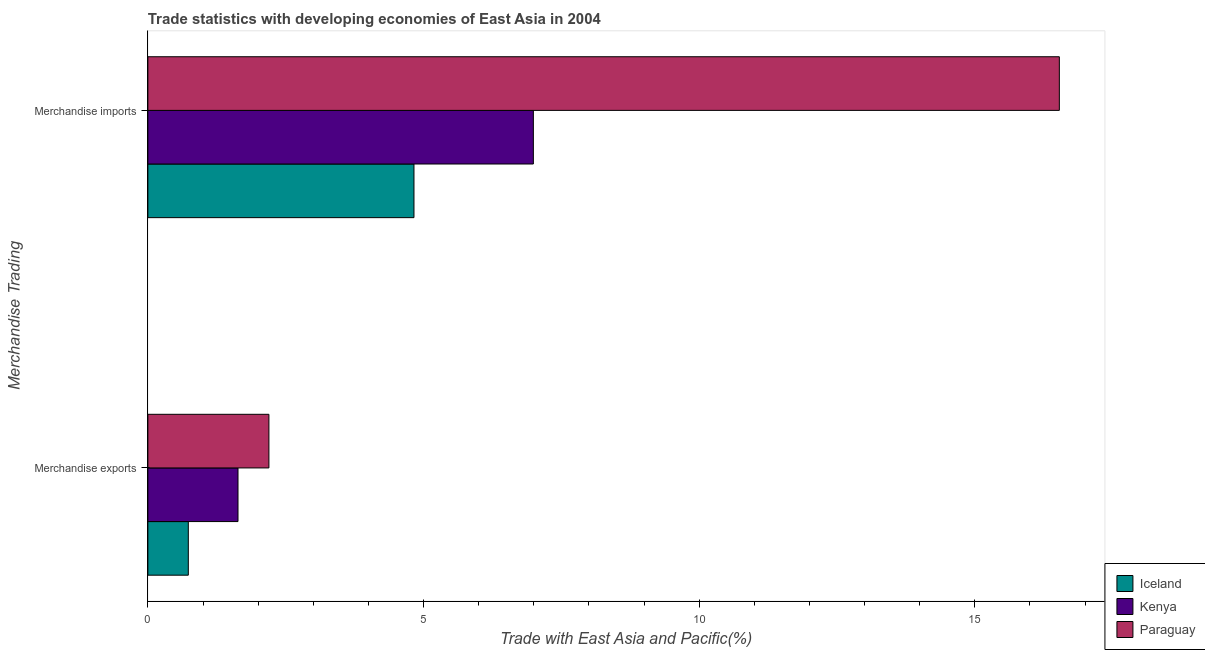How many groups of bars are there?
Provide a succinct answer. 2. Are the number of bars per tick equal to the number of legend labels?
Give a very brief answer. Yes. Are the number of bars on each tick of the Y-axis equal?
Offer a terse response. Yes. How many bars are there on the 1st tick from the bottom?
Provide a short and direct response. 3. What is the label of the 2nd group of bars from the top?
Keep it short and to the point. Merchandise exports. What is the merchandise imports in Kenya?
Ensure brevity in your answer.  6.99. Across all countries, what is the maximum merchandise imports?
Your answer should be compact. 16.53. Across all countries, what is the minimum merchandise imports?
Provide a succinct answer. 4.83. In which country was the merchandise exports maximum?
Provide a succinct answer. Paraguay. What is the total merchandise imports in the graph?
Provide a short and direct response. 28.35. What is the difference between the merchandise imports in Kenya and that in Iceland?
Make the answer very short. 2.17. What is the difference between the merchandise imports in Iceland and the merchandise exports in Kenya?
Offer a terse response. 3.19. What is the average merchandise imports per country?
Your answer should be very brief. 9.45. What is the difference between the merchandise imports and merchandise exports in Kenya?
Provide a short and direct response. 5.36. What is the ratio of the merchandise imports in Iceland to that in Kenya?
Provide a short and direct response. 0.69. In how many countries, is the merchandise imports greater than the average merchandise imports taken over all countries?
Offer a very short reply. 1. What does the 2nd bar from the top in Merchandise imports represents?
Make the answer very short. Kenya. What does the 2nd bar from the bottom in Merchandise imports represents?
Provide a short and direct response. Kenya. How many countries are there in the graph?
Your answer should be compact. 3. Are the values on the major ticks of X-axis written in scientific E-notation?
Provide a succinct answer. No. Does the graph contain any zero values?
Keep it short and to the point. No. Does the graph contain grids?
Keep it short and to the point. No. What is the title of the graph?
Offer a terse response. Trade statistics with developing economies of East Asia in 2004. What is the label or title of the X-axis?
Offer a terse response. Trade with East Asia and Pacific(%). What is the label or title of the Y-axis?
Your answer should be compact. Merchandise Trading. What is the Trade with East Asia and Pacific(%) of Iceland in Merchandise exports?
Give a very brief answer. 0.73. What is the Trade with East Asia and Pacific(%) of Kenya in Merchandise exports?
Your answer should be very brief. 1.63. What is the Trade with East Asia and Pacific(%) in Paraguay in Merchandise exports?
Ensure brevity in your answer.  2.2. What is the Trade with East Asia and Pacific(%) in Iceland in Merchandise imports?
Make the answer very short. 4.83. What is the Trade with East Asia and Pacific(%) in Kenya in Merchandise imports?
Ensure brevity in your answer.  6.99. What is the Trade with East Asia and Pacific(%) in Paraguay in Merchandise imports?
Provide a succinct answer. 16.53. Across all Merchandise Trading, what is the maximum Trade with East Asia and Pacific(%) in Iceland?
Your response must be concise. 4.83. Across all Merchandise Trading, what is the maximum Trade with East Asia and Pacific(%) in Kenya?
Your response must be concise. 6.99. Across all Merchandise Trading, what is the maximum Trade with East Asia and Pacific(%) of Paraguay?
Keep it short and to the point. 16.53. Across all Merchandise Trading, what is the minimum Trade with East Asia and Pacific(%) in Iceland?
Offer a terse response. 0.73. Across all Merchandise Trading, what is the minimum Trade with East Asia and Pacific(%) of Kenya?
Your answer should be compact. 1.63. Across all Merchandise Trading, what is the minimum Trade with East Asia and Pacific(%) in Paraguay?
Ensure brevity in your answer.  2.2. What is the total Trade with East Asia and Pacific(%) in Iceland in the graph?
Provide a succinct answer. 5.56. What is the total Trade with East Asia and Pacific(%) in Kenya in the graph?
Ensure brevity in your answer.  8.63. What is the total Trade with East Asia and Pacific(%) in Paraguay in the graph?
Offer a very short reply. 18.73. What is the difference between the Trade with East Asia and Pacific(%) of Iceland in Merchandise exports and that in Merchandise imports?
Give a very brief answer. -4.09. What is the difference between the Trade with East Asia and Pacific(%) of Kenya in Merchandise exports and that in Merchandise imports?
Make the answer very short. -5.36. What is the difference between the Trade with East Asia and Pacific(%) in Paraguay in Merchandise exports and that in Merchandise imports?
Provide a succinct answer. -14.34. What is the difference between the Trade with East Asia and Pacific(%) in Iceland in Merchandise exports and the Trade with East Asia and Pacific(%) in Kenya in Merchandise imports?
Your answer should be compact. -6.26. What is the difference between the Trade with East Asia and Pacific(%) in Iceland in Merchandise exports and the Trade with East Asia and Pacific(%) in Paraguay in Merchandise imports?
Provide a succinct answer. -15.8. What is the difference between the Trade with East Asia and Pacific(%) in Kenya in Merchandise exports and the Trade with East Asia and Pacific(%) in Paraguay in Merchandise imports?
Provide a succinct answer. -14.9. What is the average Trade with East Asia and Pacific(%) of Iceland per Merchandise Trading?
Ensure brevity in your answer.  2.78. What is the average Trade with East Asia and Pacific(%) in Kenya per Merchandise Trading?
Your answer should be very brief. 4.31. What is the average Trade with East Asia and Pacific(%) in Paraguay per Merchandise Trading?
Offer a terse response. 9.36. What is the difference between the Trade with East Asia and Pacific(%) of Iceland and Trade with East Asia and Pacific(%) of Kenya in Merchandise exports?
Provide a short and direct response. -0.9. What is the difference between the Trade with East Asia and Pacific(%) of Iceland and Trade with East Asia and Pacific(%) of Paraguay in Merchandise exports?
Your answer should be very brief. -1.46. What is the difference between the Trade with East Asia and Pacific(%) in Kenya and Trade with East Asia and Pacific(%) in Paraguay in Merchandise exports?
Your answer should be very brief. -0.56. What is the difference between the Trade with East Asia and Pacific(%) in Iceland and Trade with East Asia and Pacific(%) in Kenya in Merchandise imports?
Give a very brief answer. -2.17. What is the difference between the Trade with East Asia and Pacific(%) of Iceland and Trade with East Asia and Pacific(%) of Paraguay in Merchandise imports?
Ensure brevity in your answer.  -11.71. What is the difference between the Trade with East Asia and Pacific(%) of Kenya and Trade with East Asia and Pacific(%) of Paraguay in Merchandise imports?
Your response must be concise. -9.54. What is the ratio of the Trade with East Asia and Pacific(%) in Iceland in Merchandise exports to that in Merchandise imports?
Provide a short and direct response. 0.15. What is the ratio of the Trade with East Asia and Pacific(%) of Kenya in Merchandise exports to that in Merchandise imports?
Your answer should be very brief. 0.23. What is the ratio of the Trade with East Asia and Pacific(%) of Paraguay in Merchandise exports to that in Merchandise imports?
Keep it short and to the point. 0.13. What is the difference between the highest and the second highest Trade with East Asia and Pacific(%) in Iceland?
Ensure brevity in your answer.  4.09. What is the difference between the highest and the second highest Trade with East Asia and Pacific(%) in Kenya?
Make the answer very short. 5.36. What is the difference between the highest and the second highest Trade with East Asia and Pacific(%) in Paraguay?
Your answer should be compact. 14.34. What is the difference between the highest and the lowest Trade with East Asia and Pacific(%) of Iceland?
Your response must be concise. 4.09. What is the difference between the highest and the lowest Trade with East Asia and Pacific(%) of Kenya?
Give a very brief answer. 5.36. What is the difference between the highest and the lowest Trade with East Asia and Pacific(%) of Paraguay?
Your answer should be very brief. 14.34. 